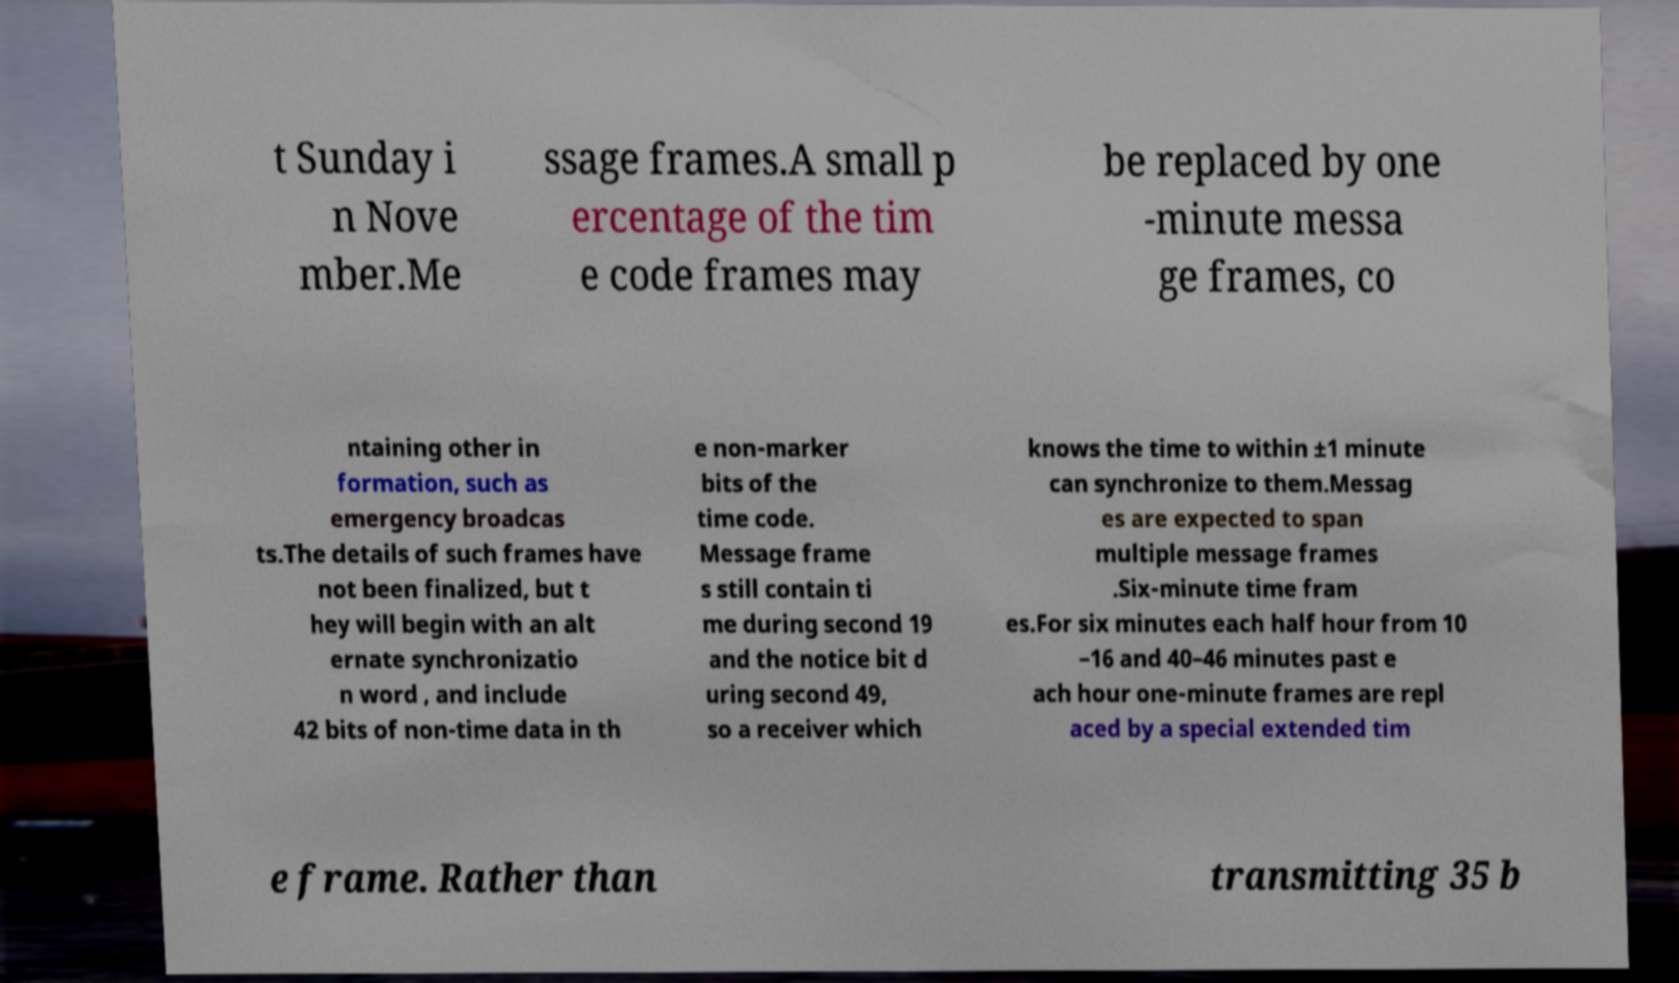Can you read and provide the text displayed in the image?This photo seems to have some interesting text. Can you extract and type it out for me? t Sunday i n Nove mber.Me ssage frames.A small p ercentage of the tim e code frames may be replaced by one -minute messa ge frames, co ntaining other in formation, such as emergency broadcas ts.The details of such frames have not been finalized, but t hey will begin with an alt ernate synchronizatio n word , and include 42 bits of non-time data in th e non-marker bits of the time code. Message frame s still contain ti me during second 19 and the notice bit d uring second 49, so a receiver which knows the time to within ±1 minute can synchronize to them.Messag es are expected to span multiple message frames .Six-minute time fram es.For six minutes each half hour from 10 –16 and 40–46 minutes past e ach hour one-minute frames are repl aced by a special extended tim e frame. Rather than transmitting 35 b 